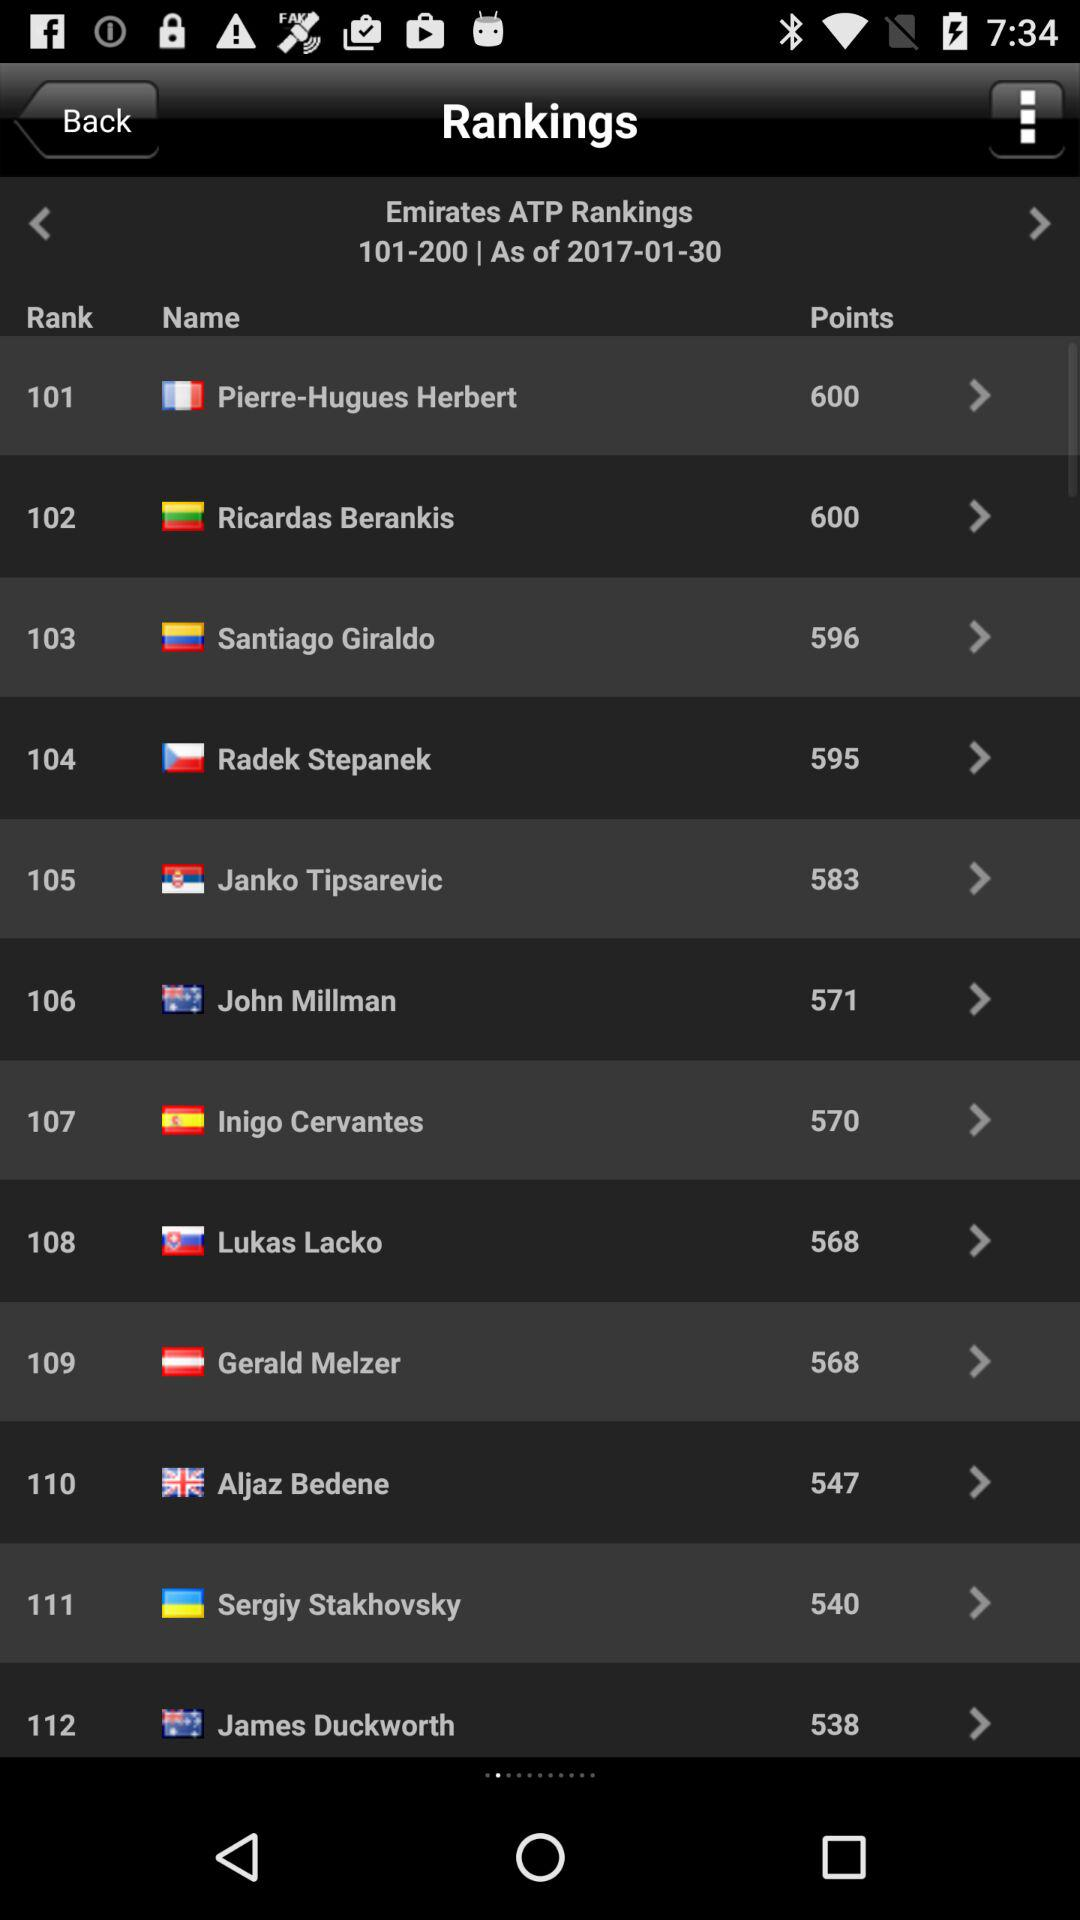Till what date have the rankings been shown? The rankings have been shown until January 30, 2017. 